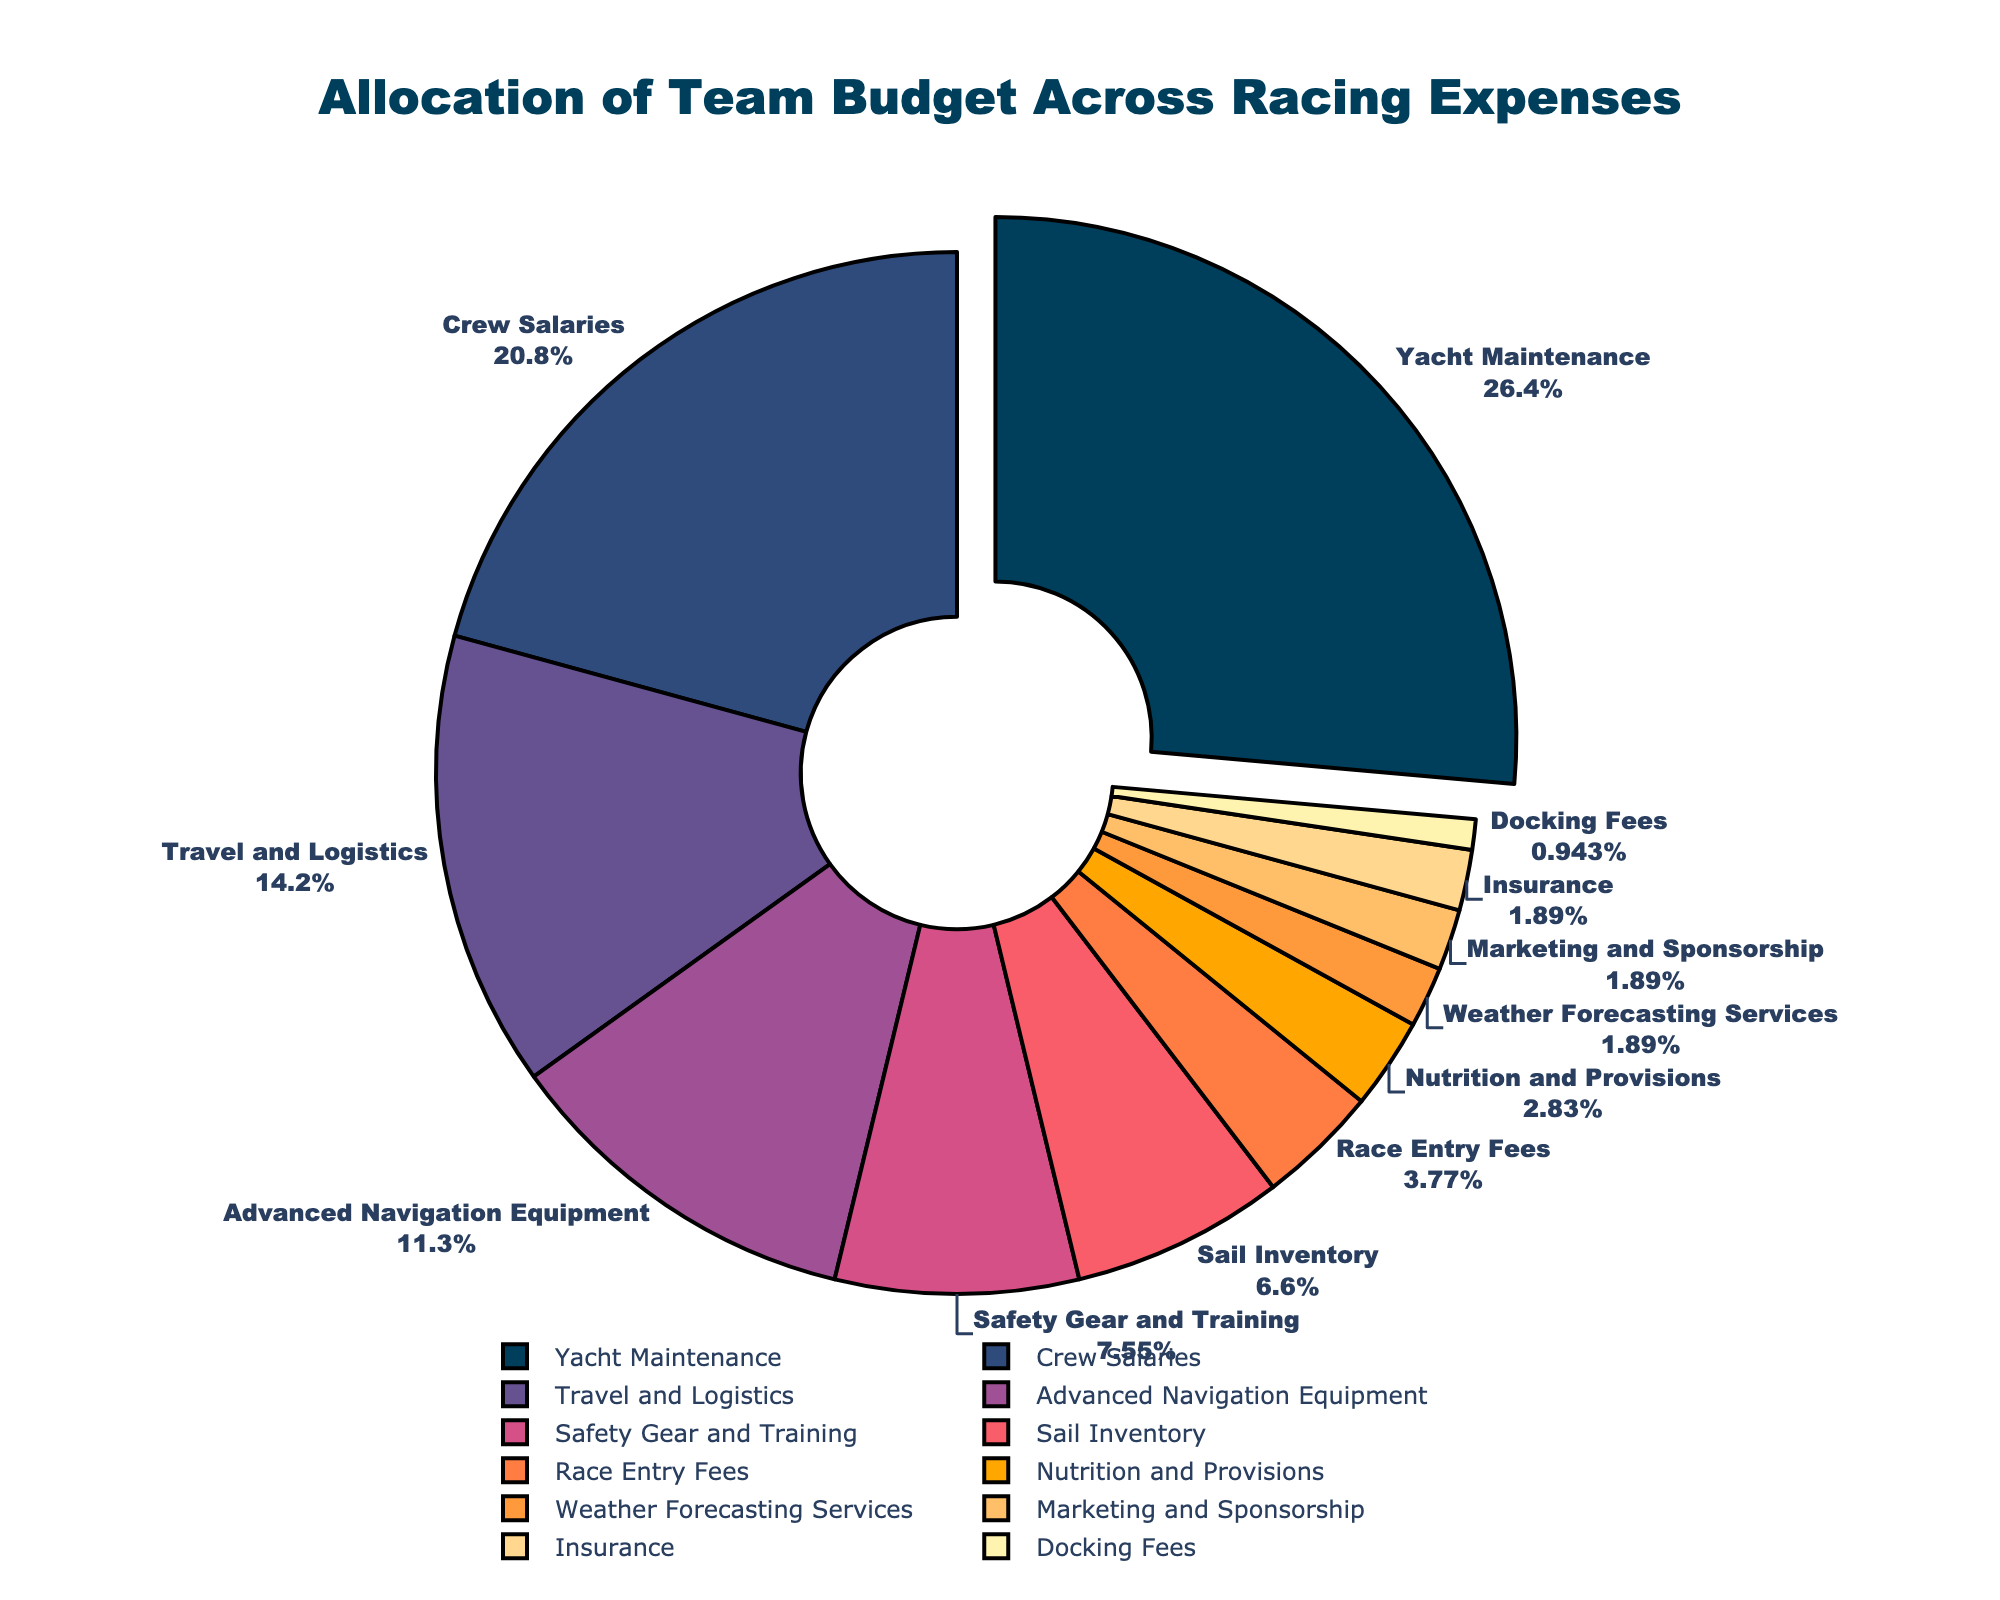What is the largest expense category in the team's budget? The largest expense category is identified by looking for the slice with the highest percentage. In this case, it is Yacht Maintenance at 28%.
Answer: Yacht Maintenance Which expense category has the smallest allocation and what is its percentage? The smallest expense category is identified by finding the slice with the lowest percentage. Here, it is Docking Fees at 1%.
Answer: Docking Fees, 1% How much more is allocated to crew salaries compared to sail inventory? To find this, subtract the percentage allocated to sail inventory from the percentage allocated to crew salaries: 22% - 7% = 15%.
Answer: 15% What is the total percentage allocated to safety gear and training, nutrition and provisions, and weather forecasting services? To find the total percentage, sum the values of these three categories: 8% (Safety Gear and Training) + 3% (Nutrition and Provisions) + 2% (Weather Forecasting Services) = 13%.
Answer: 13% Is the percentage allocated to advanced navigation equipment greater than the total percentage for travel and logistics, and weather forecasting services combined? First, sum the percentages for Travel and Logistics and Weather Forecasting Services: 15% + 2% = 17%. Compare this to Advanced Navigation Equipment at 12%. 12% is less than 17%.
Answer: No What percentage is allocated to expenses related to safety, including safety gear and insurance? Sum the percentages for Safety Gear and Training and Insurance: 8% + 2% = 10%.
Answer: 10% Which expense categories have a budget allocation of less than 5%? These categories are identified by finding the slices with percentages less than 5%. They are Race Entry Fees (4%), Nutrition and Provisions (3%), Weather Forecasting Services (2%), Marketing and Sponsorship (2%), Insurance (2%), and Docking Fees (1%).
Answer: Race Entry Fees, Nutrition and Provisions, Weather Forecasting Services, Marketing and Sponsorship, Insurance, Docking Fees How much more is allocated to yacht maintenance compared to the combined percentage for marketing and sponsorship, and insurance? First, sum the percentages for Marketing and Sponsorship, and Insurance: 2% + 2% = 4%. Then, subtract this from the percentage for Yacht Maintenance: 28% - 4% = 24%.
Answer: 24% What categories occupy the top three spots in allocation and what are their percentages? The top three slices, based on percentage, are Yacht Maintenance (28%), Crew Salaries (22%), and Travel and Logistics (15%).
Answer: Yacht Maintenance (28%), Crew Salaries (22%), Travel and Logistics (15%) Which expense categories are represented in shades of red and what are their percentages? The categories associated with shades of red are identified visually as follows: Advanced Navigation Equipment (12%, dark red) and Safety Gear and Training (8%, lighter red).
Answer: Advanced Navigation Equipment (12%), Safety Gear and Training (8%) 